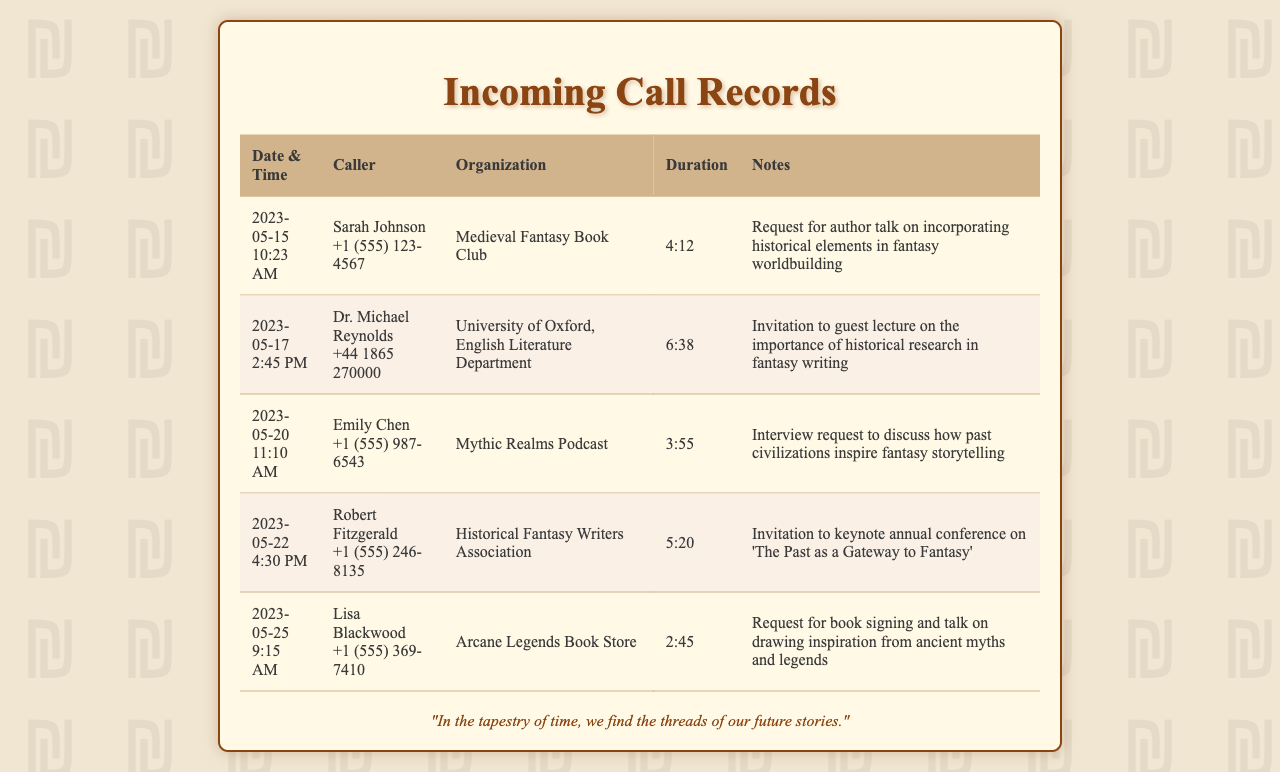What is the date of the first call? The first call is dated May 15, 2023.
Answer: May 15, 2023 Who called from the University of Oxford? The call from the University of Oxford was made by Dr. Michael Reynolds.
Answer: Dr. Michael Reynolds How long was the call with the Historical Fantasy Writers Association? The duration of the call with the Historical Fantasy Writers Association was 5 minutes and 20 seconds.
Answer: 5:20 What organization reached out for an author talk on historical elements in fantasy writing? The Medieval Fantasy Book Club requested the author talk on historical elements.
Answer: Medieval Fantasy Book Club Which caller requested a book signing and talk? Lisa Blackwood requested a book signing and talk.
Answer: Lisa Blackwood What is the duration of the interview request from Mythic Realms Podcast? The interview request from Mythic Realms Podcast lasted for 3 minutes and 55 seconds.
Answer: 3:55 What was the topic of the keynote invitation from the Historical Fantasy Writers Association? The keynote invitation was on 'The Past as a Gateway to Fantasy'.
Answer: The Past as a Gateway to Fantasy How many calls are listed in the document? There are five calls listed in the document.
Answer: Five What time did Lisa Blackwood's call occur? Lisa Blackwood's call occurred at 9:15 AM.
Answer: 9:15 AM 